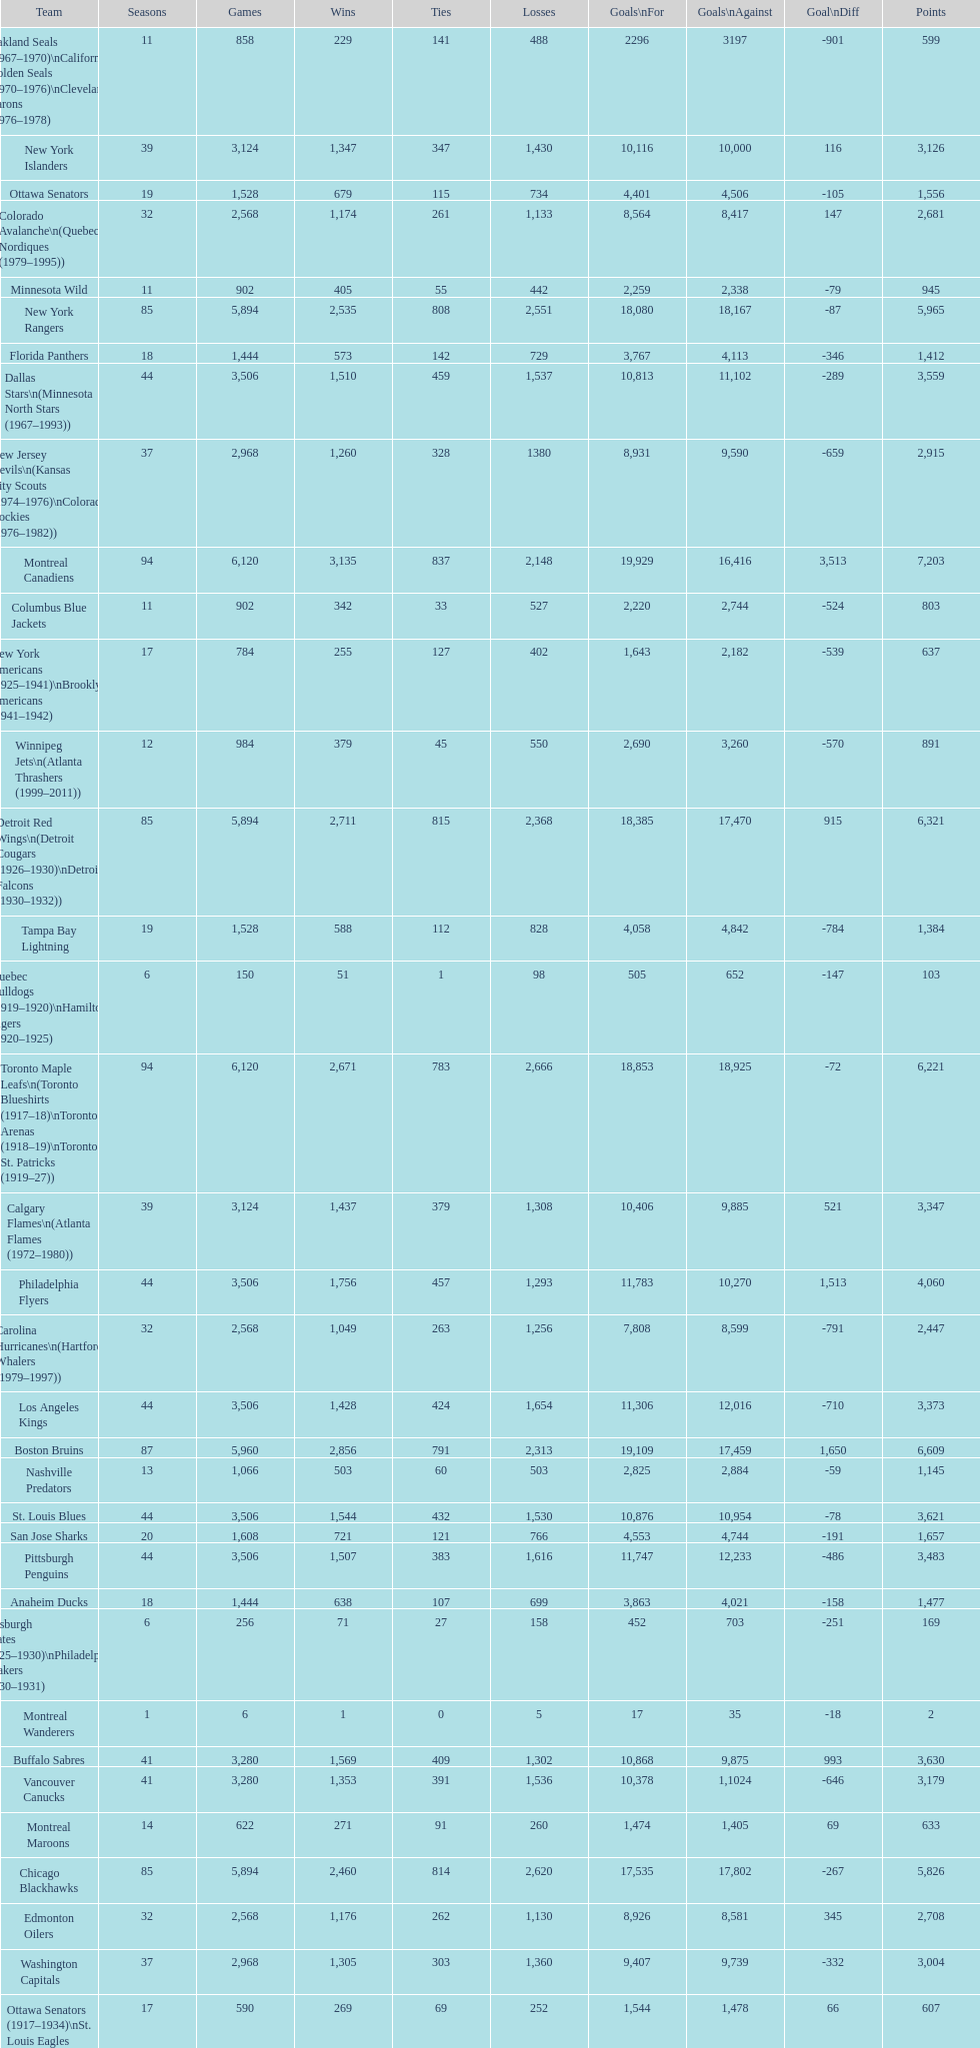Who has the least amount of losses? Montreal Wanderers. Would you mind parsing the complete table? {'header': ['Team', 'Seasons', 'Games', 'Wins', 'Ties', 'Losses', 'Goals\\nFor', 'Goals\\nAgainst', 'Goal\\nDiff', 'Points'], 'rows': [['Oakland Seals (1967–1970)\\nCalifornia Golden Seals (1970–1976)\\nCleveland Barons (1976–1978)', '11', '858', '229', '141', '488', '2296', '3197', '-901', '599'], ['New York Islanders', '39', '3,124', '1,347', '347', '1,430', '10,116', '10,000', '116', '3,126'], ['Ottawa Senators', '19', '1,528', '679', '115', '734', '4,401', '4,506', '-105', '1,556'], ['Colorado Avalanche\\n(Quebec Nordiques (1979–1995))', '32', '2,568', '1,174', '261', '1,133', '8,564', '8,417', '147', '2,681'], ['Minnesota Wild', '11', '902', '405', '55', '442', '2,259', '2,338', '-79', '945'], ['New York Rangers', '85', '5,894', '2,535', '808', '2,551', '18,080', '18,167', '-87', '5,965'], ['Florida Panthers', '18', '1,444', '573', '142', '729', '3,767', '4,113', '-346', '1,412'], ['Dallas Stars\\n(Minnesota North Stars (1967–1993))', '44', '3,506', '1,510', '459', '1,537', '10,813', '11,102', '-289', '3,559'], ['New Jersey Devils\\n(Kansas City Scouts (1974–1976)\\nColorado Rockies (1976–1982))', '37', '2,968', '1,260', '328', '1380', '8,931', '9,590', '-659', '2,915'], ['Montreal Canadiens', '94', '6,120', '3,135', '837', '2,148', '19,929', '16,416', '3,513', '7,203'], ['Columbus Blue Jackets', '11', '902', '342', '33', '527', '2,220', '2,744', '-524', '803'], ['New York Americans (1925–1941)\\nBrooklyn Americans (1941–1942)', '17', '784', '255', '127', '402', '1,643', '2,182', '-539', '637'], ['Winnipeg Jets\\n(Atlanta Thrashers (1999–2011))', '12', '984', '379', '45', '550', '2,690', '3,260', '-570', '891'], ['Detroit Red Wings\\n(Detroit Cougars (1926–1930)\\nDetroit Falcons (1930–1932))', '85', '5,894', '2,711', '815', '2,368', '18,385', '17,470', '915', '6,321'], ['Tampa Bay Lightning', '19', '1,528', '588', '112', '828', '4,058', '4,842', '-784', '1,384'], ['Quebec Bulldogs (1919–1920)\\nHamilton Tigers (1920–1925)', '6', '150', '51', '1', '98', '505', '652', '-147', '103'], ['Toronto Maple Leafs\\n(Toronto Blueshirts (1917–18)\\nToronto Arenas (1918–19)\\nToronto St. Patricks (1919–27))', '94', '6,120', '2,671', '783', '2,666', '18,853', '18,925', '-72', '6,221'], ['Calgary Flames\\n(Atlanta Flames (1972–1980))', '39', '3,124', '1,437', '379', '1,308', '10,406', '9,885', '521', '3,347'], ['Philadelphia Flyers', '44', '3,506', '1,756', '457', '1,293', '11,783', '10,270', '1,513', '4,060'], ['Carolina Hurricanes\\n(Hartford Whalers (1979–1997))', '32', '2,568', '1,049', '263', '1,256', '7,808', '8,599', '-791', '2,447'], ['Los Angeles Kings', '44', '3,506', '1,428', '424', '1,654', '11,306', '12,016', '-710', '3,373'], ['Boston Bruins', '87', '5,960', '2,856', '791', '2,313', '19,109', '17,459', '1,650', '6,609'], ['Nashville Predators', '13', '1,066', '503', '60', '503', '2,825', '2,884', '-59', '1,145'], ['St. Louis Blues', '44', '3,506', '1,544', '432', '1,530', '10,876', '10,954', '-78', '3,621'], ['San Jose Sharks', '20', '1,608', '721', '121', '766', '4,553', '4,744', '-191', '1,657'], ['Pittsburgh Penguins', '44', '3,506', '1,507', '383', '1,616', '11,747', '12,233', '-486', '3,483'], ['Anaheim Ducks', '18', '1,444', '638', '107', '699', '3,863', '4,021', '-158', '1,477'], ['Pittsburgh Pirates (1925–1930)\\nPhiladelphia Quakers (1930–1931)', '6', '256', '71', '27', '158', '452', '703', '-251', '169'], ['Montreal Wanderers', '1', '6', '1', '0', '5', '17', '35', '-18', '2'], ['Buffalo Sabres', '41', '3,280', '1,569', '409', '1,302', '10,868', '9,875', '993', '3,630'], ['Vancouver Canucks', '41', '3,280', '1,353', '391', '1,536', '10,378', '1,1024', '-646', '3,179'], ['Montreal Maroons', '14', '622', '271', '91', '260', '1,474', '1,405', '69', '633'], ['Chicago Blackhawks', '85', '5,894', '2,460', '814', '2,620', '17,535', '17,802', '-267', '5,826'], ['Edmonton Oilers', '32', '2,568', '1,176', '262', '1,130', '8,926', '8,581', '345', '2,708'], ['Washington Capitals', '37', '2,968', '1,305', '303', '1,360', '9,407', '9,739', '-332', '3,004'], ['Ottawa Senators (1917–1934)\\nSt. Louis Eagles (1934–1935)', '17', '590', '269', '69', '252', '1,544', '1,478', '66', '607'], ['Phoenix Coyotes\\n(Winnipeg Jets (1979–1996))', '32', '2,568', '1,063', '266', '1,239', '8,058', '8,809', '-756', '2,473']]} 